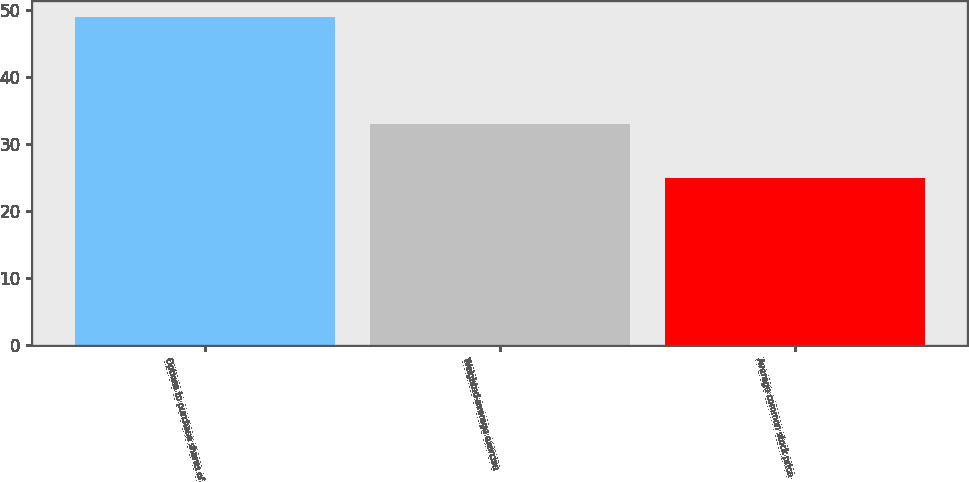Convert chart to OTSL. <chart><loc_0><loc_0><loc_500><loc_500><bar_chart><fcel>Options to purchase shares of<fcel>Weighted-average exercise<fcel>Average common stock price<nl><fcel>49<fcel>33<fcel>25<nl></chart> 